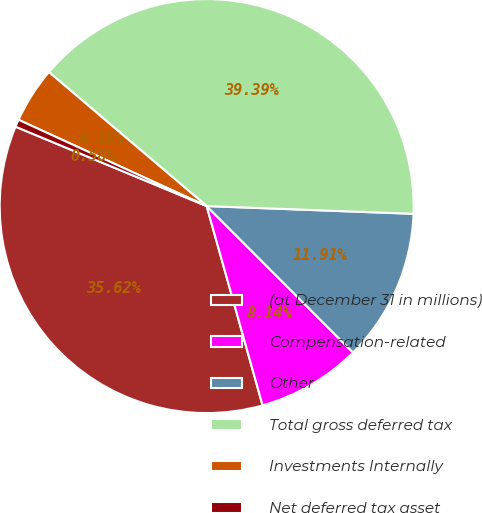Convert chart. <chart><loc_0><loc_0><loc_500><loc_500><pie_chart><fcel>(at December 31 in millions)<fcel>Compensation-related<fcel>Other<fcel>Total gross deferred tax<fcel>Investments Internally<fcel>Net deferred tax asset<nl><fcel>35.62%<fcel>8.14%<fcel>11.91%<fcel>39.39%<fcel>4.36%<fcel>0.58%<nl></chart> 